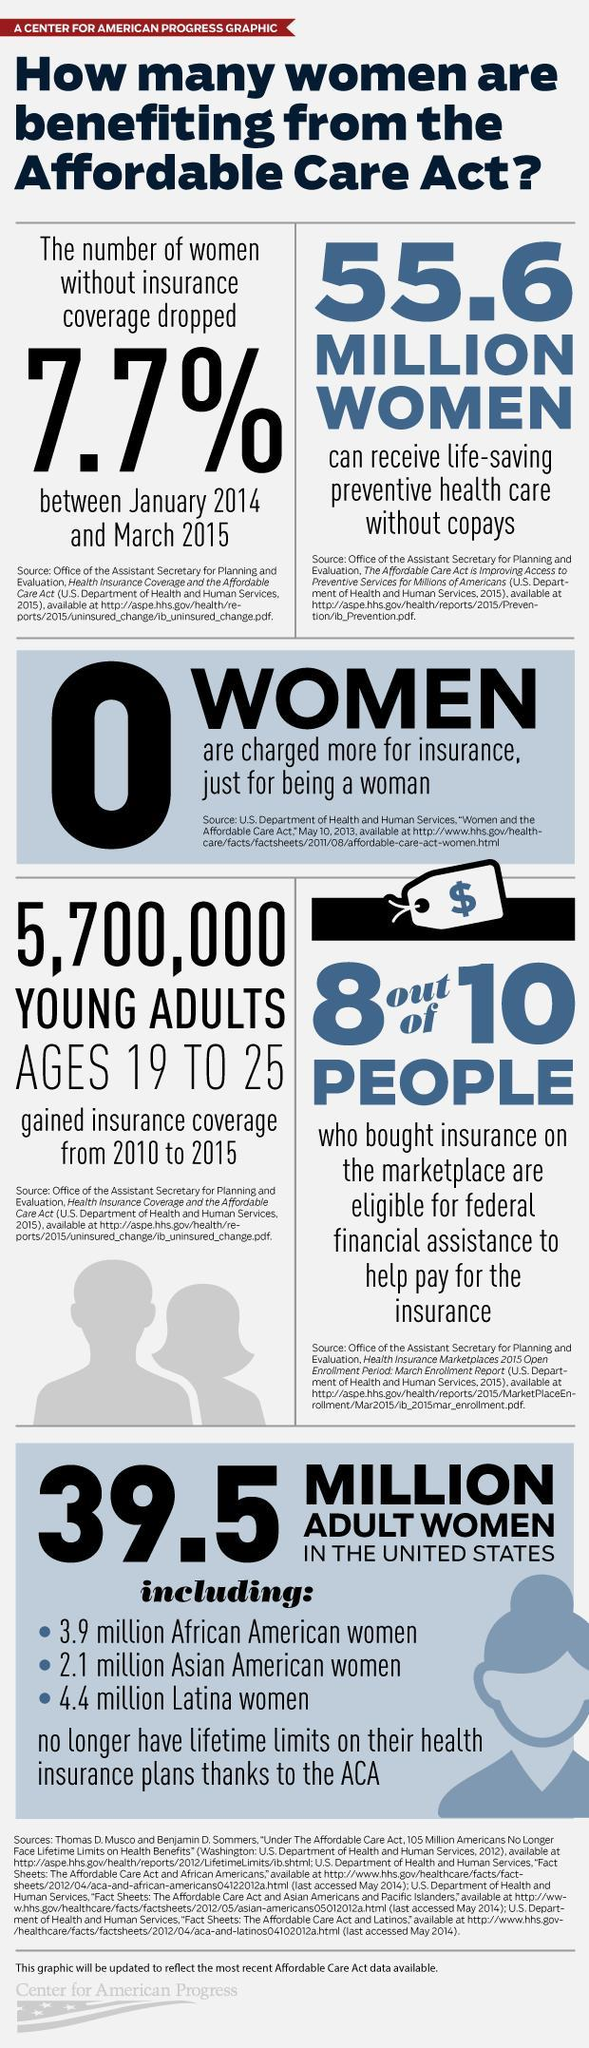What is the total number of adult women belonging to the ethnic race groups, African, Asian, and Latina?
Answer the question with a short phrase. 10.4 million 